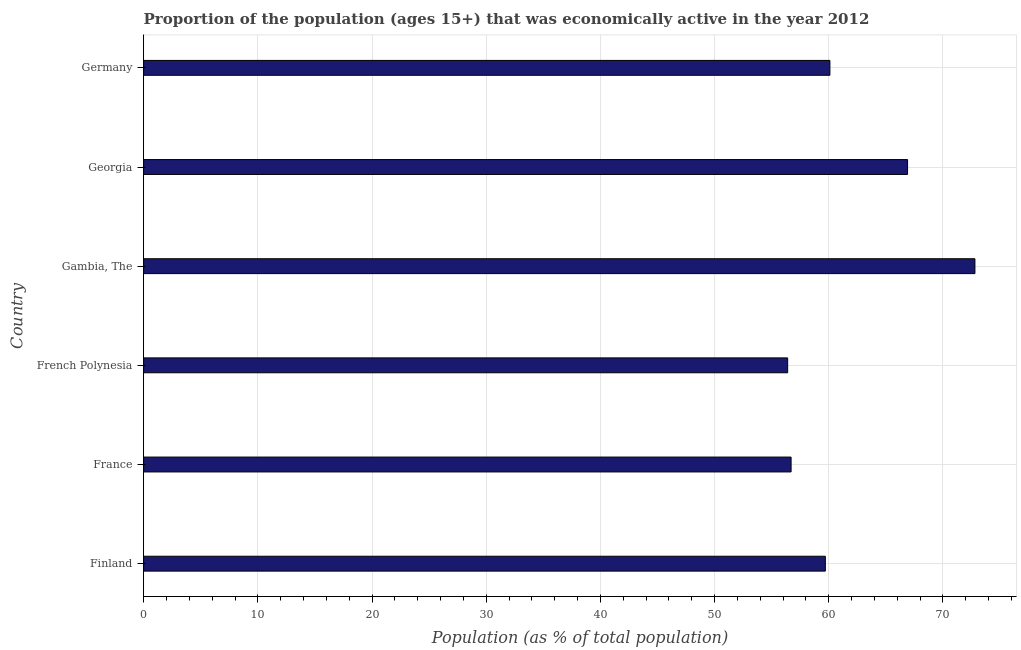What is the title of the graph?
Provide a succinct answer. Proportion of the population (ages 15+) that was economically active in the year 2012. What is the label or title of the X-axis?
Your answer should be compact. Population (as % of total population). What is the percentage of economically active population in French Polynesia?
Your answer should be very brief. 56.4. Across all countries, what is the maximum percentage of economically active population?
Offer a terse response. 72.8. Across all countries, what is the minimum percentage of economically active population?
Offer a terse response. 56.4. In which country was the percentage of economically active population maximum?
Offer a very short reply. Gambia, The. In which country was the percentage of economically active population minimum?
Provide a succinct answer. French Polynesia. What is the sum of the percentage of economically active population?
Your answer should be very brief. 372.6. What is the average percentage of economically active population per country?
Keep it short and to the point. 62.1. What is the median percentage of economically active population?
Your response must be concise. 59.9. In how many countries, is the percentage of economically active population greater than 52 %?
Your response must be concise. 6. What is the ratio of the percentage of economically active population in France to that in Germany?
Your response must be concise. 0.94. Is the difference between the percentage of economically active population in Gambia, The and Germany greater than the difference between any two countries?
Keep it short and to the point. No. In how many countries, is the percentage of economically active population greater than the average percentage of economically active population taken over all countries?
Offer a very short reply. 2. How many bars are there?
Give a very brief answer. 6. Are all the bars in the graph horizontal?
Give a very brief answer. Yes. What is the difference between two consecutive major ticks on the X-axis?
Provide a succinct answer. 10. Are the values on the major ticks of X-axis written in scientific E-notation?
Your response must be concise. No. What is the Population (as % of total population) of Finland?
Offer a very short reply. 59.7. What is the Population (as % of total population) of France?
Offer a very short reply. 56.7. What is the Population (as % of total population) of French Polynesia?
Ensure brevity in your answer.  56.4. What is the Population (as % of total population) of Gambia, The?
Your answer should be compact. 72.8. What is the Population (as % of total population) in Georgia?
Make the answer very short. 66.9. What is the Population (as % of total population) in Germany?
Offer a very short reply. 60.1. What is the difference between the Population (as % of total population) in Finland and France?
Give a very brief answer. 3. What is the difference between the Population (as % of total population) in Finland and French Polynesia?
Your answer should be compact. 3.3. What is the difference between the Population (as % of total population) in Finland and Gambia, The?
Your answer should be compact. -13.1. What is the difference between the Population (as % of total population) in France and Gambia, The?
Your response must be concise. -16.1. What is the difference between the Population (as % of total population) in France and Georgia?
Keep it short and to the point. -10.2. What is the difference between the Population (as % of total population) in France and Germany?
Ensure brevity in your answer.  -3.4. What is the difference between the Population (as % of total population) in French Polynesia and Gambia, The?
Your response must be concise. -16.4. What is the difference between the Population (as % of total population) in French Polynesia and Germany?
Keep it short and to the point. -3.7. What is the difference between the Population (as % of total population) in Gambia, The and Georgia?
Your answer should be compact. 5.9. What is the ratio of the Population (as % of total population) in Finland to that in France?
Your answer should be very brief. 1.05. What is the ratio of the Population (as % of total population) in Finland to that in French Polynesia?
Offer a terse response. 1.06. What is the ratio of the Population (as % of total population) in Finland to that in Gambia, The?
Your answer should be very brief. 0.82. What is the ratio of the Population (as % of total population) in Finland to that in Georgia?
Provide a succinct answer. 0.89. What is the ratio of the Population (as % of total population) in France to that in Gambia, The?
Provide a succinct answer. 0.78. What is the ratio of the Population (as % of total population) in France to that in Georgia?
Your answer should be very brief. 0.85. What is the ratio of the Population (as % of total population) in France to that in Germany?
Offer a terse response. 0.94. What is the ratio of the Population (as % of total population) in French Polynesia to that in Gambia, The?
Make the answer very short. 0.78. What is the ratio of the Population (as % of total population) in French Polynesia to that in Georgia?
Offer a terse response. 0.84. What is the ratio of the Population (as % of total population) in French Polynesia to that in Germany?
Ensure brevity in your answer.  0.94. What is the ratio of the Population (as % of total population) in Gambia, The to that in Georgia?
Offer a very short reply. 1.09. What is the ratio of the Population (as % of total population) in Gambia, The to that in Germany?
Ensure brevity in your answer.  1.21. What is the ratio of the Population (as % of total population) in Georgia to that in Germany?
Offer a very short reply. 1.11. 